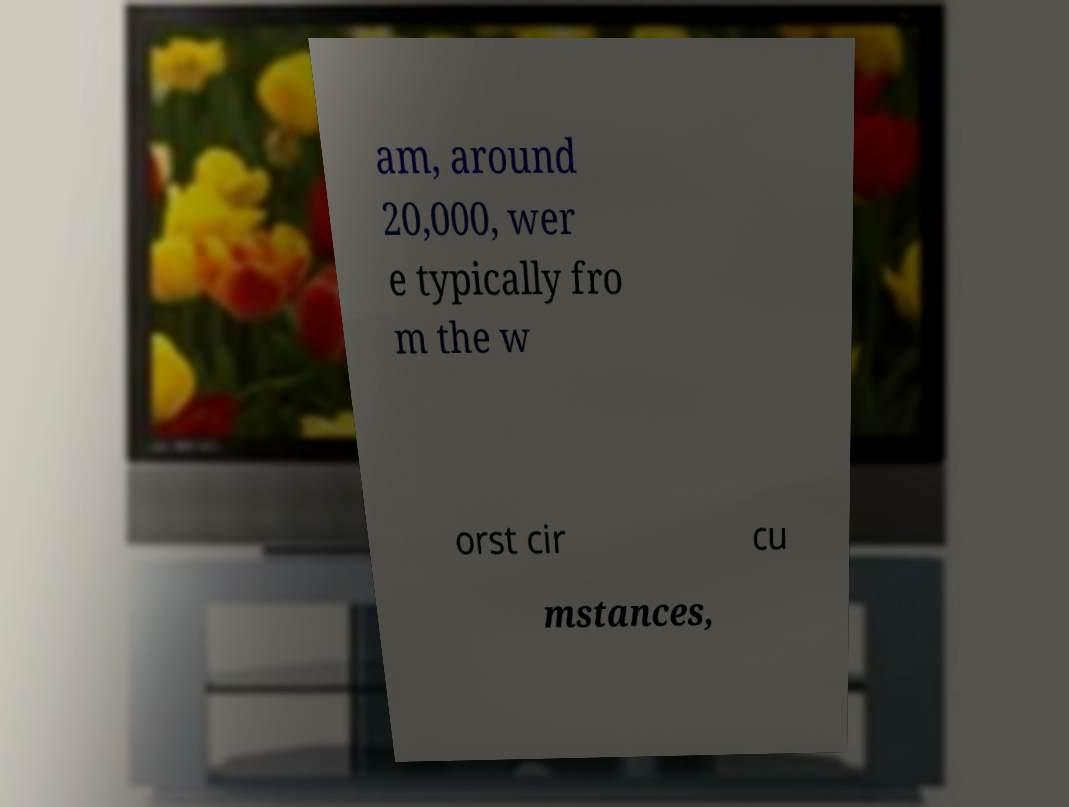I need the written content from this picture converted into text. Can you do that? am, around 20,000, wer e typically fro m the w orst cir cu mstances, 